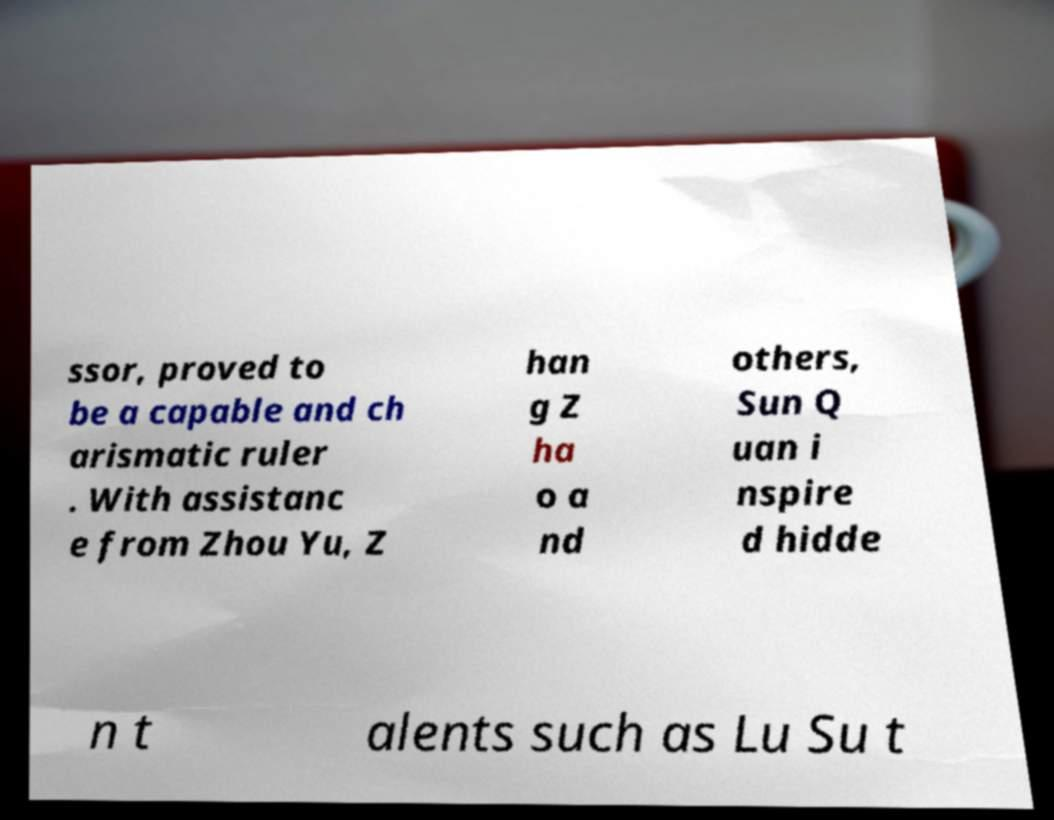For documentation purposes, I need the text within this image transcribed. Could you provide that? ssor, proved to be a capable and ch arismatic ruler . With assistanc e from Zhou Yu, Z han g Z ha o a nd others, Sun Q uan i nspire d hidde n t alents such as Lu Su t 